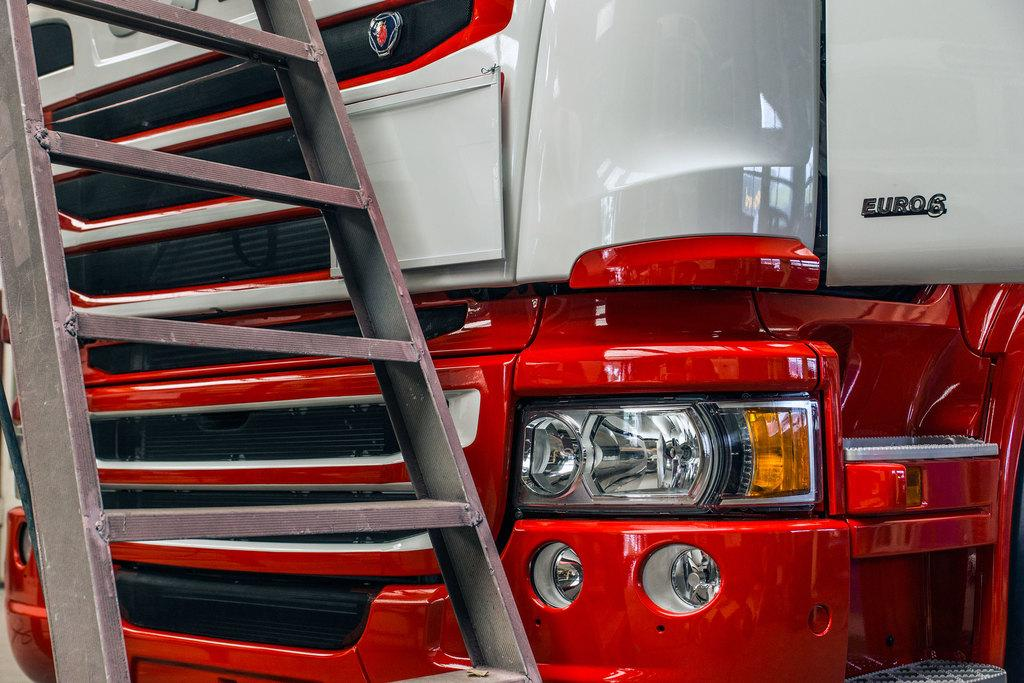What object can be seen in the picture that is used for climbing or reaching higher places? There is a ladder in the picture. What type of vehicle is partially visible in the picture? There is a front part of a vehicle in the picture. How does the seed shake in the picture? There is no seed present in the picture, so it cannot be shaking. 